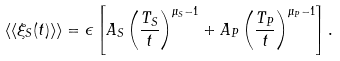Convert formula to latex. <formula><loc_0><loc_0><loc_500><loc_500>\langle \langle \xi _ { S } ( t ) \rangle \rangle = \epsilon \left [ A _ { S } \left ( \frac { T _ { S } } { t } \right ) ^ { \mu _ { S } - 1 } + A _ { P } \left ( \frac { T _ { P } } { t } \right ) ^ { \mu _ { P } - 1 } \right ] .</formula> 